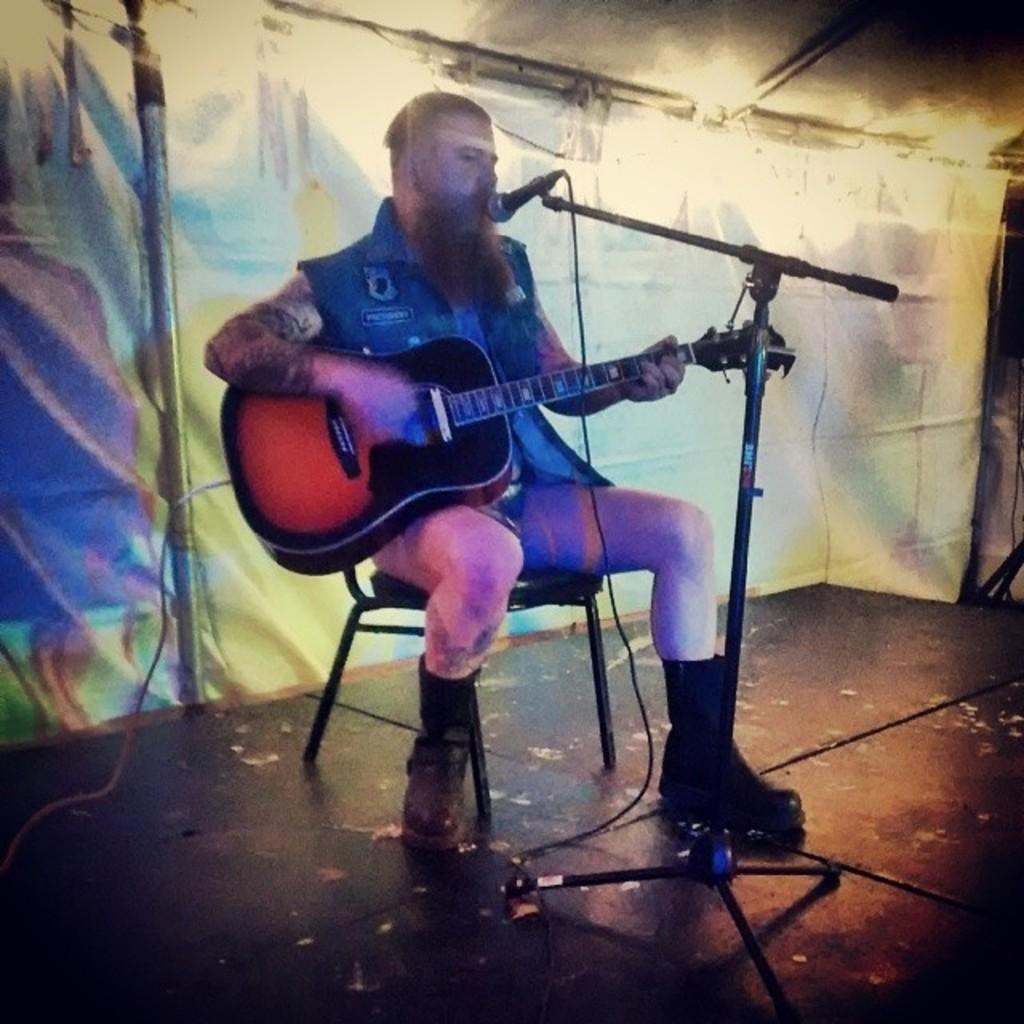Who is the main subject in the image? There is a man in the image. What is the man doing in the image? The man is sitting on a chair, playing a guitar, and singing a song. What can be seen in the background of the image? There is a curtain in the background of the image. What type of jewel is the man wearing on his head in the image? There is no jewel visible on the man's head in the image. Can you see any snails crawling on the curtain in the background? There are no snails present in the image, and the curtain is not shown in enough detail to determine if any snails might be crawling on it. 